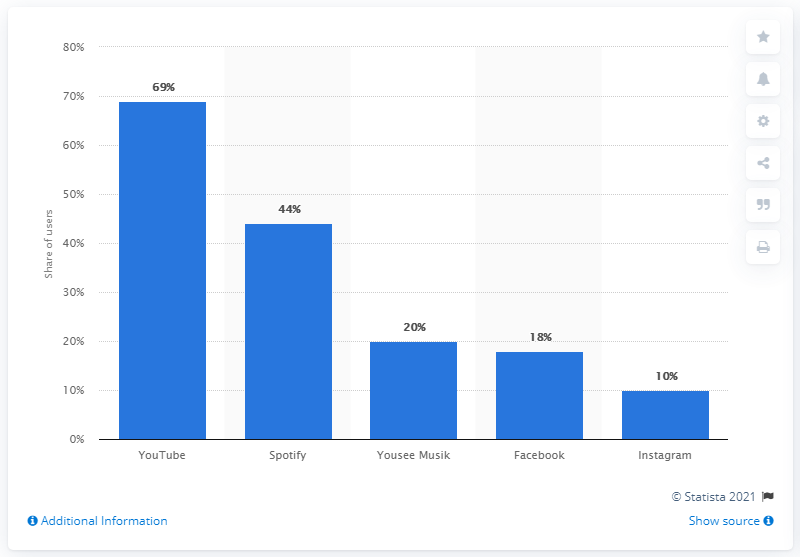What is the most used digital music service in Denmark? According to the bar chart, YouTube is the most popular digital music service in Denmark, with a 69% share of users, followed by Spotify with a 44% share. Such data reflects digital consumption habits and indicates YouTube's dominance in the digital music streaming market within the country. 